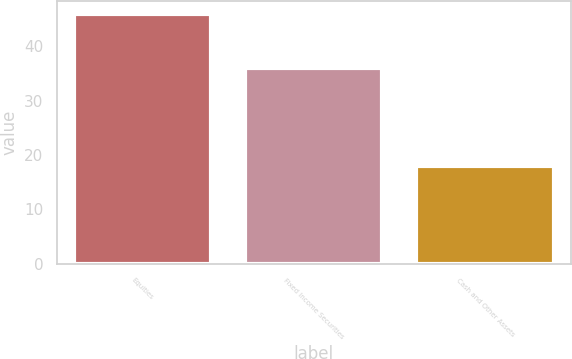<chart> <loc_0><loc_0><loc_500><loc_500><bar_chart><fcel>Equities<fcel>Fixed Income Securities<fcel>Cash and Other Assets<nl><fcel>46<fcel>36<fcel>18<nl></chart> 